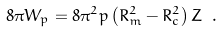Convert formula to latex. <formula><loc_0><loc_0><loc_500><loc_500>8 \pi W _ { p } = 8 \pi ^ { 2 } p \left ( R ^ { 2 } _ { m } - R ^ { 2 } _ { c } \right ) Z \ .</formula> 